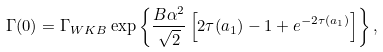<formula> <loc_0><loc_0><loc_500><loc_500>\Gamma ( 0 ) = \Gamma _ { W K B } \exp \left \{ \frac { B \alpha ^ { 2 } } { \sqrt { 2 } } \left [ 2 \tau ( a _ { 1 } ) - 1 + e ^ { - 2 \tau ( a _ { 1 } ) } \right ] \right \} ,</formula> 